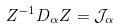<formula> <loc_0><loc_0><loc_500><loc_500>Z ^ { - 1 } D _ { \alpha } Z = \mathcal { J } _ { \alpha }</formula> 